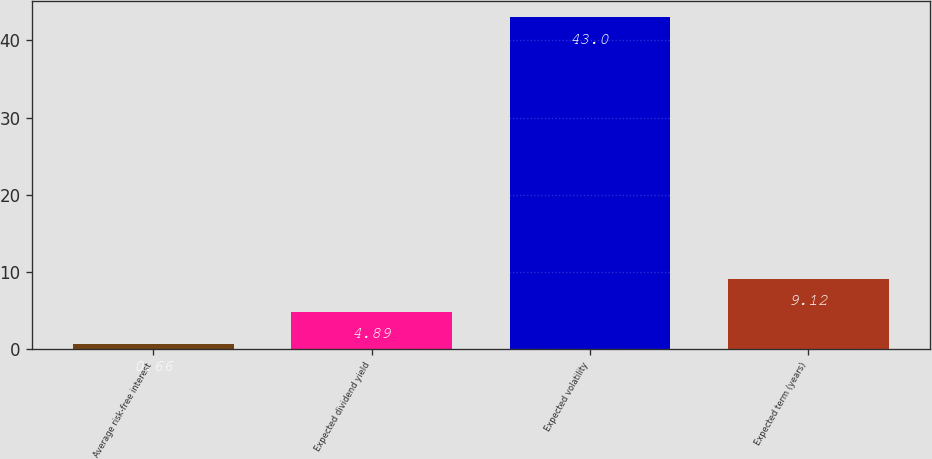Convert chart to OTSL. <chart><loc_0><loc_0><loc_500><loc_500><bar_chart><fcel>Average risk-free interest<fcel>Expected dividend yield<fcel>Expected volatility<fcel>Expected term (years)<nl><fcel>0.66<fcel>4.89<fcel>43<fcel>9.12<nl></chart> 